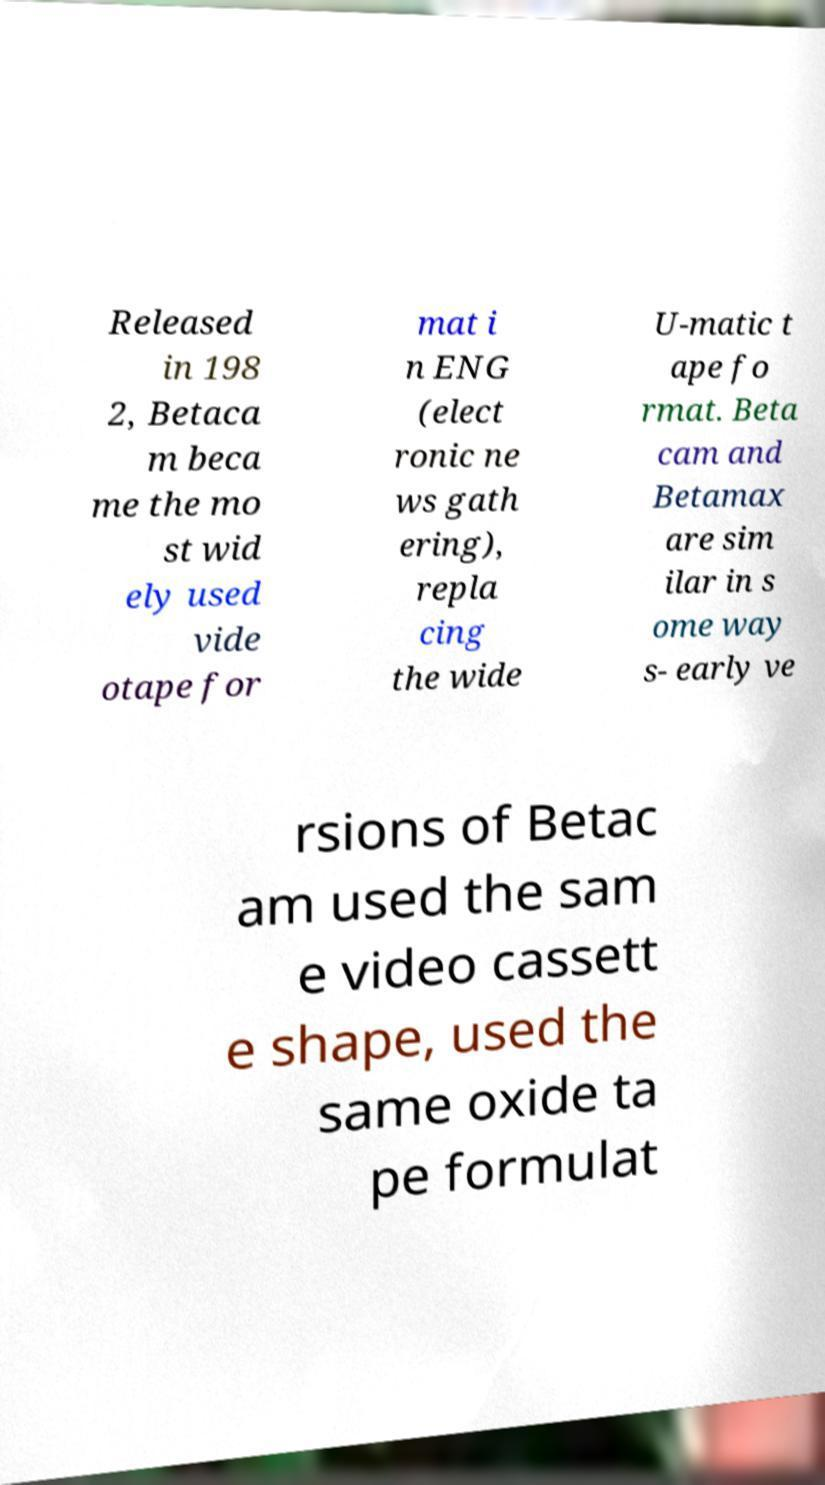Please identify and transcribe the text found in this image. Released in 198 2, Betaca m beca me the mo st wid ely used vide otape for mat i n ENG (elect ronic ne ws gath ering), repla cing the wide U-matic t ape fo rmat. Beta cam and Betamax are sim ilar in s ome way s- early ve rsions of Betac am used the sam e video cassett e shape, used the same oxide ta pe formulat 